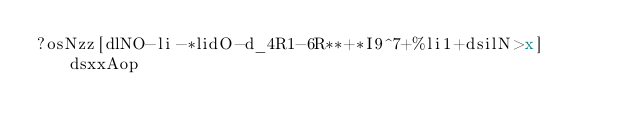<code> <loc_0><loc_0><loc_500><loc_500><_dc_>?osNzz[dlNO-li-*lidO-d_4R1-6R**+*I9^7+%li1+dsilN>x]dsxxAop</code> 